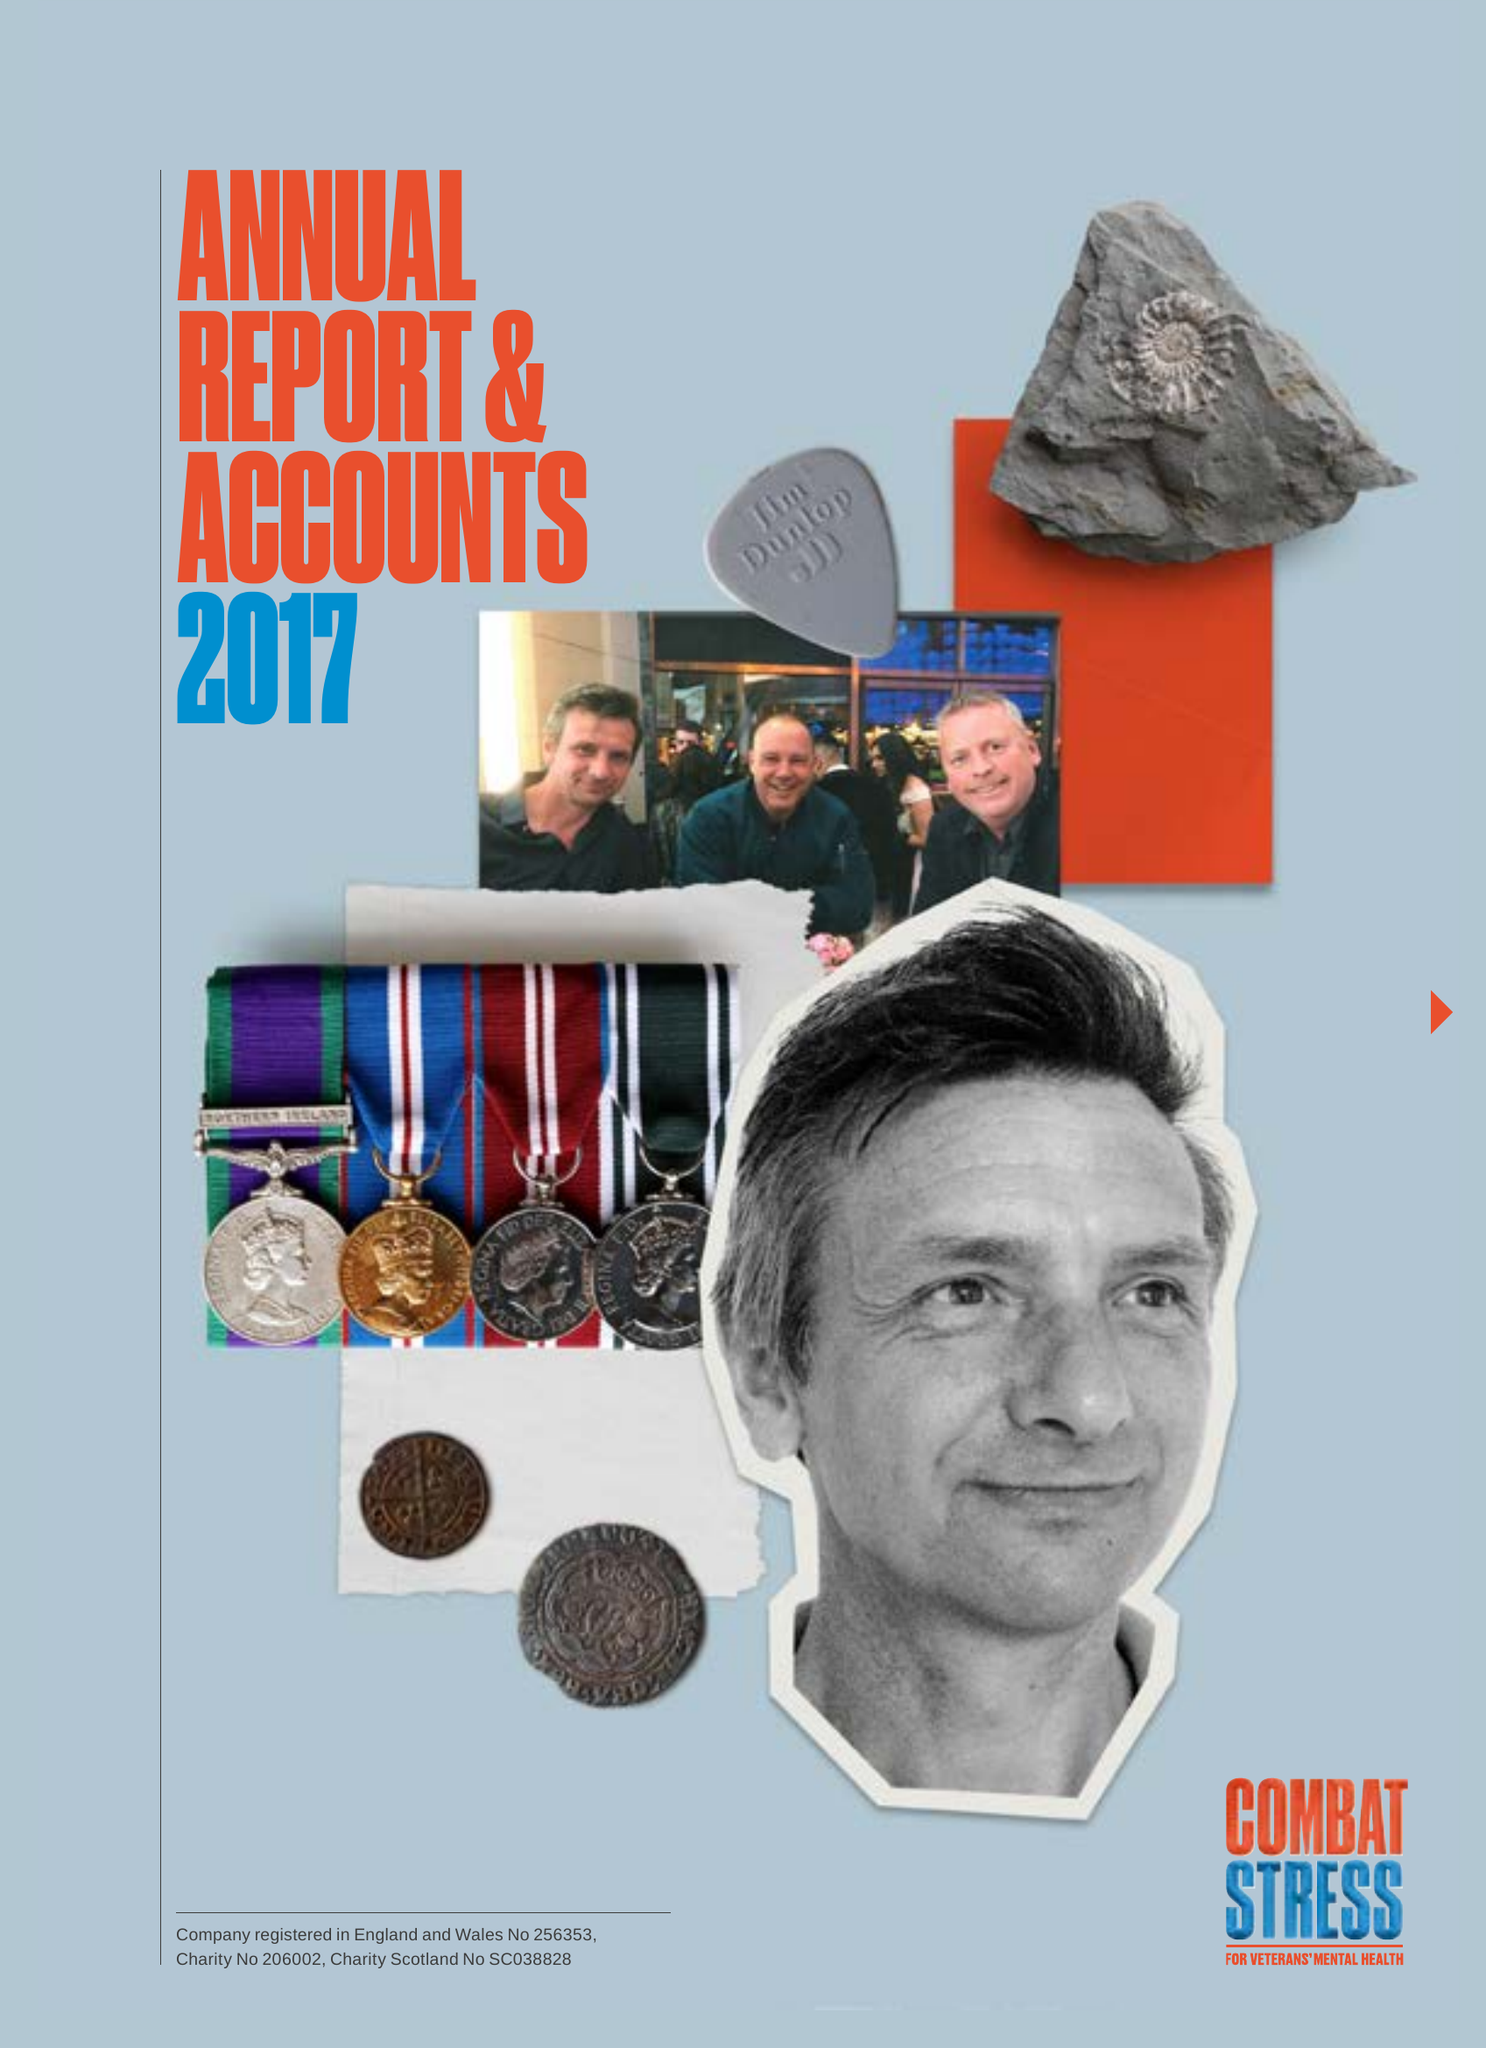What is the value for the income_annually_in_british_pounds?
Answer the question using a single word or phrase. 15709000.00 